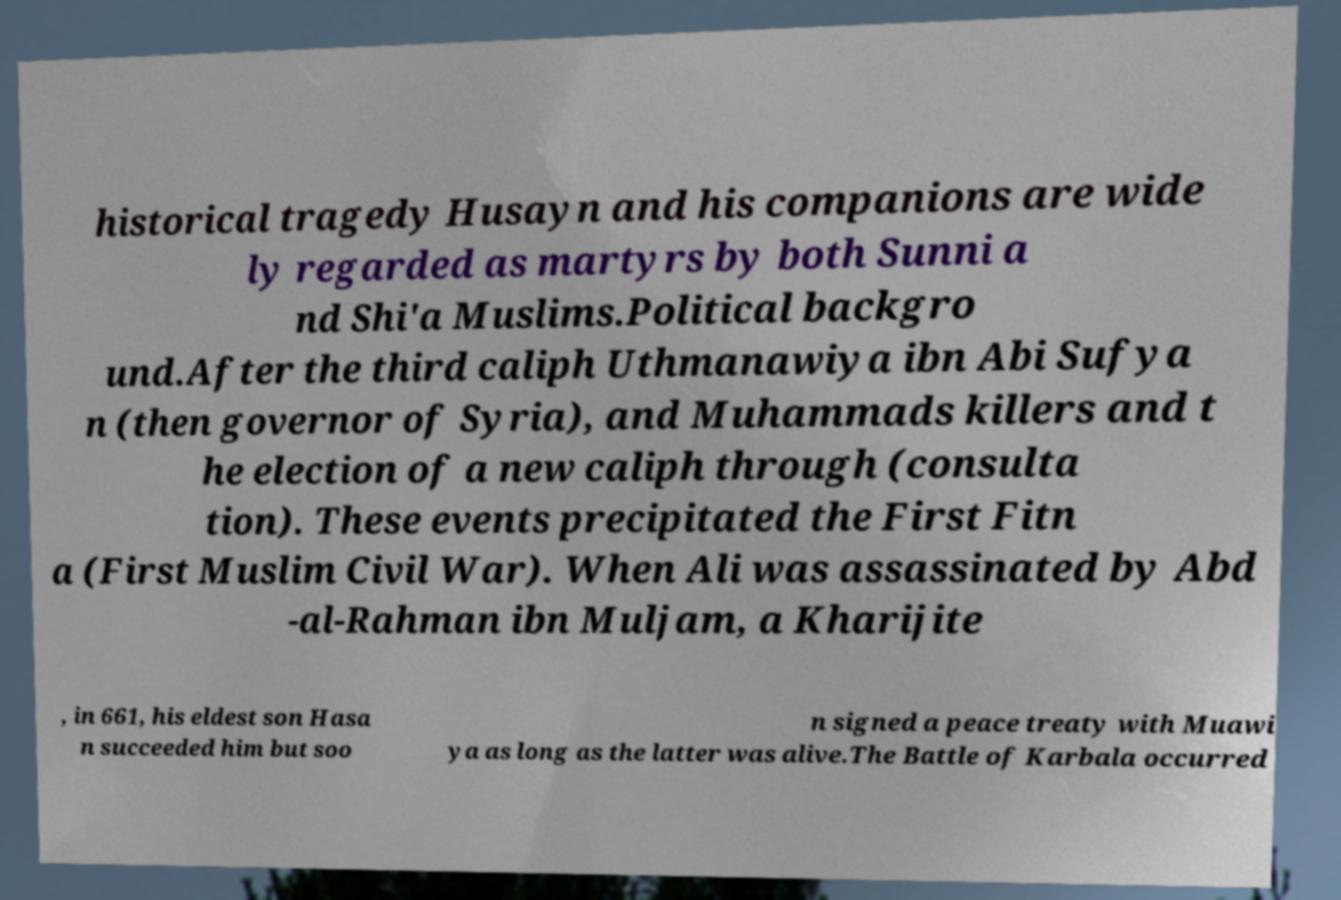What messages or text are displayed in this image? I need them in a readable, typed format. historical tragedy Husayn and his companions are wide ly regarded as martyrs by both Sunni a nd Shi'a Muslims.Political backgro und.After the third caliph Uthmanawiya ibn Abi Sufya n (then governor of Syria), and Muhammads killers and t he election of a new caliph through (consulta tion). These events precipitated the First Fitn a (First Muslim Civil War). When Ali was assassinated by Abd -al-Rahman ibn Muljam, a Kharijite , in 661, his eldest son Hasa n succeeded him but soo n signed a peace treaty with Muawi ya as long as the latter was alive.The Battle of Karbala occurred 